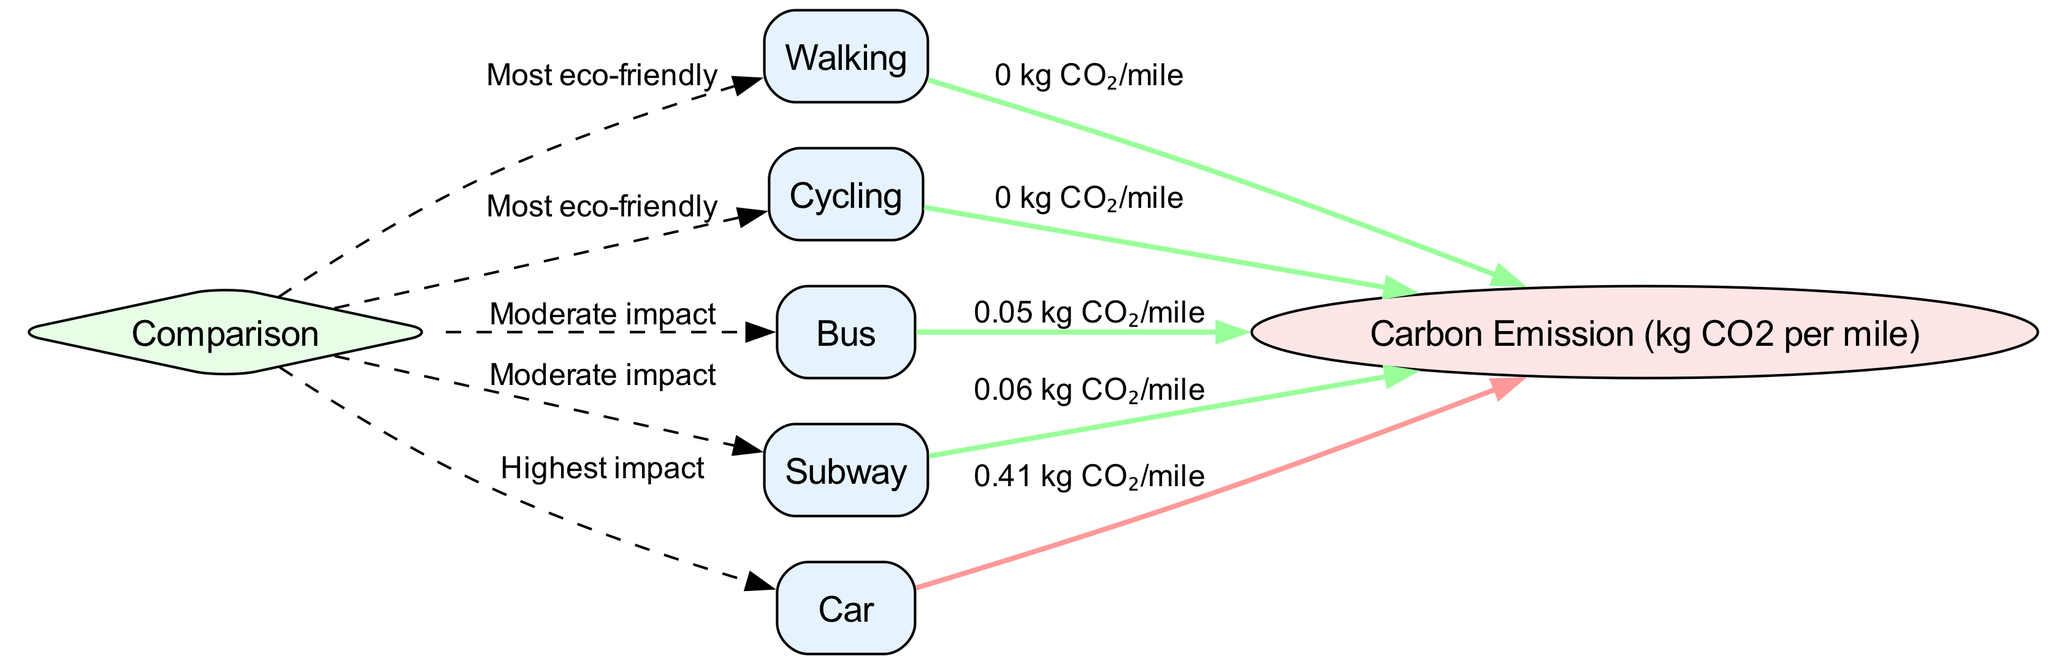What are the two transport modes with zero carbon emissions? The diagram shows 'Walking' and 'Cycling' connected to the 'Carbon Emission' node, both labeled with a carbon emission value of '0'.
Answer: Walking, Cycling Which transport mode has the highest carbon emissions? The diagram indicates that 'Car' points to the 'Carbon Emission' node with a value of '0.41', which is the highest among all modes shown.
Answer: Car How many transportation modes are featured in the diagram? By counting the nodes in the 'nodes' section, there are five transport modes: Walking, Cycling, Bus, Subway, and Car, making a total of five modes.
Answer: 5 Which modes are categorized as having a moderate impact? The diagram provides labels through the 'Comparison' node that shows 'Bus' and 'Subway' as having the 'Moderate impact' classification.
Answer: Bus, Subway What carbon emission value is associated with the metro subway system? Following the edge leading from 'Subway' to 'Carbon Emission', the value displayed is '0.06', indicating the carbon emissions per mile for the subway.
Answer: 0.06 Which transportation mode is labeled as the most eco-friendly? The diagram classifies both 'Walking' and 'Cycling' as 'Most eco-friendly', as indicated by the edges from 'Comparison' node.
Answer: Walking, Cycling How many edges connect transport modes to the carbon emission metric? Reviewing the edges, there are five connections from transport modes to the 'Carbon Emission' metric, representing the carbon emissions per mode.
Answer: 5 What is the carbon emission value linked to using a bus? The diagram links 'Bus' to the 'Carbon Emission' node with a value of '0.05', representing the emissions per mile for this mode of transport.
Answer: 0.05 If I want to travel with the least environmental impact, which mode should I choose? The diagram indicates that 'Walking' and 'Cycling' both have zero carbon emissions, making them the best choices for lowering environmental impact.
Answer: Walking, Cycling 